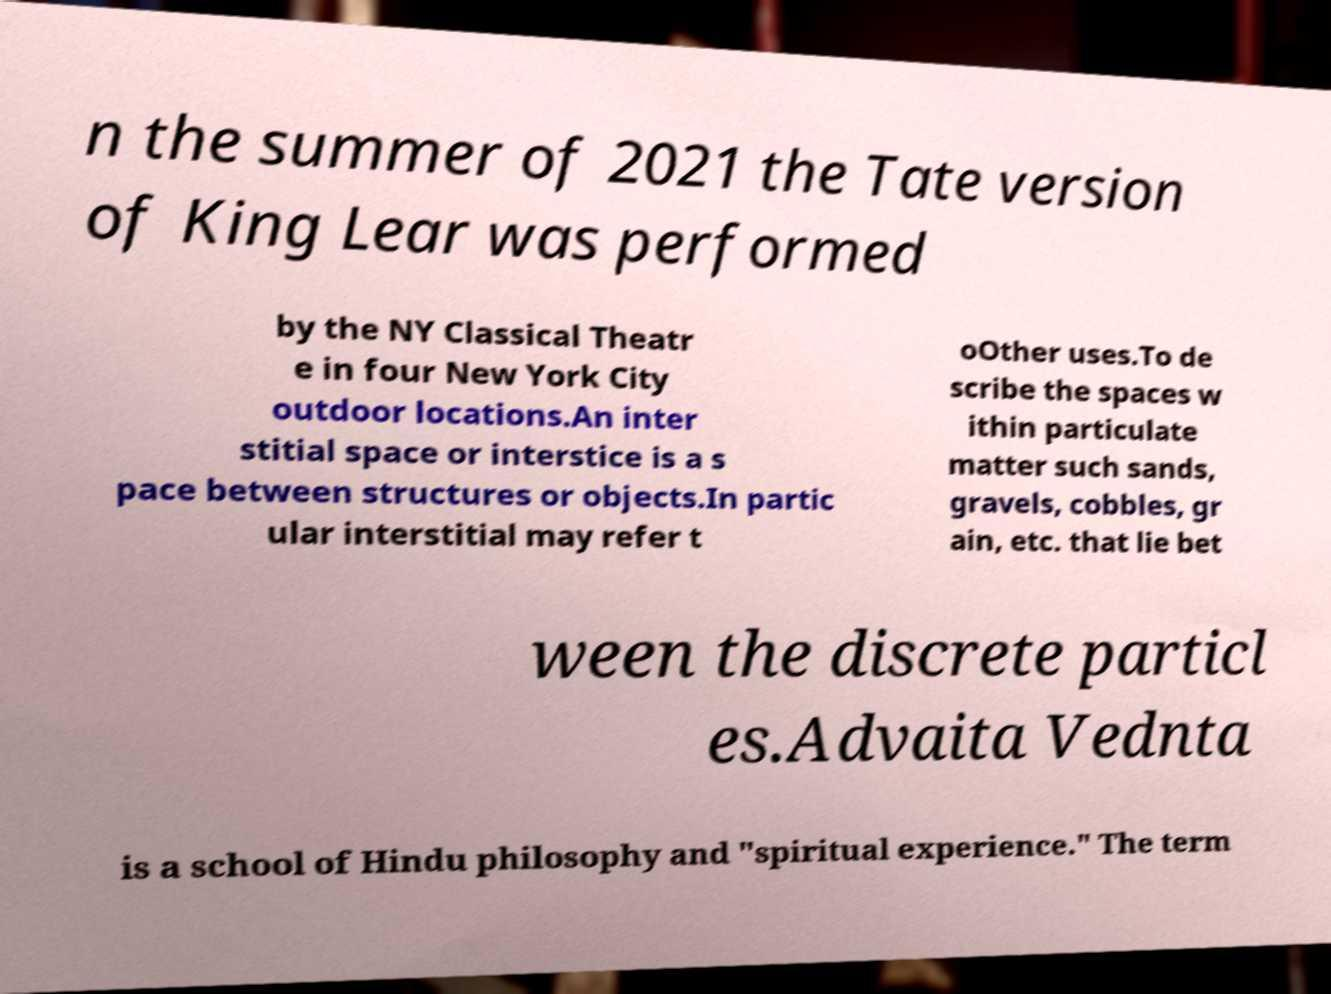For documentation purposes, I need the text within this image transcribed. Could you provide that? n the summer of 2021 the Tate version of King Lear was performed by the NY Classical Theatr e in four New York City outdoor locations.An inter stitial space or interstice is a s pace between structures or objects.In partic ular interstitial may refer t oOther uses.To de scribe the spaces w ithin particulate matter such sands, gravels, cobbles, gr ain, etc. that lie bet ween the discrete particl es.Advaita Vednta is a school of Hindu philosophy and "spiritual experience." The term 